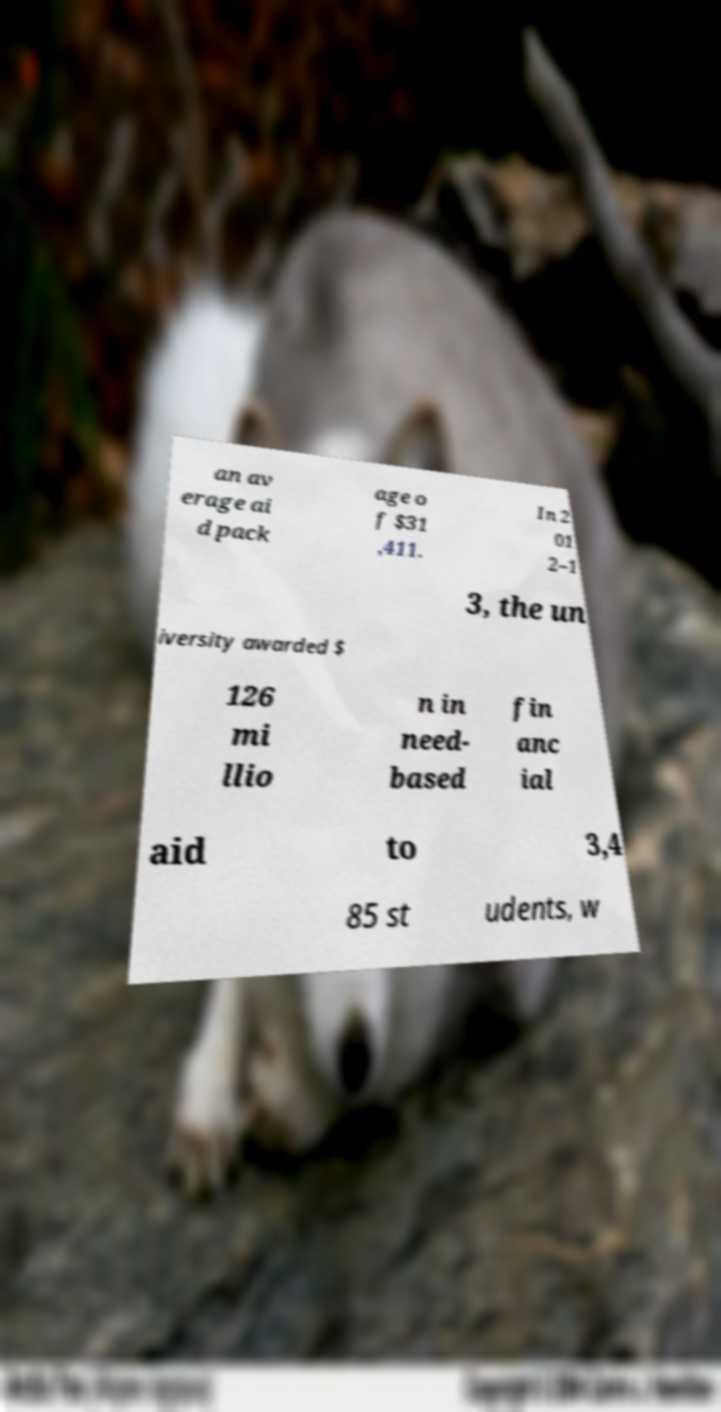I need the written content from this picture converted into text. Can you do that? an av erage ai d pack age o f $31 ,411. In 2 01 2–1 3, the un iversity awarded $ 126 mi llio n in need- based fin anc ial aid to 3,4 85 st udents, w 